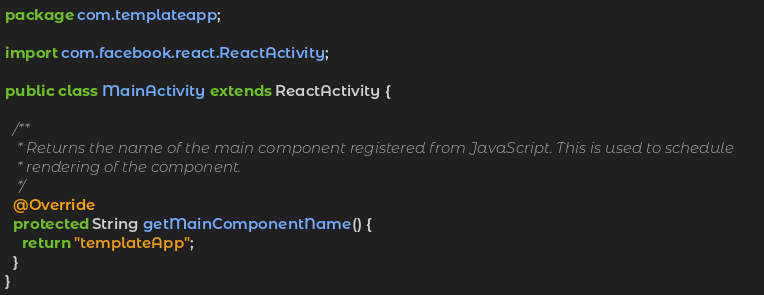<code> <loc_0><loc_0><loc_500><loc_500><_Java_>package com.templateapp;

import com.facebook.react.ReactActivity;

public class MainActivity extends ReactActivity {

  /**
   * Returns the name of the main component registered from JavaScript. This is used to schedule
   * rendering of the component.
   */
  @Override
  protected String getMainComponentName() {
    return "templateApp";
  }
}
</code> 